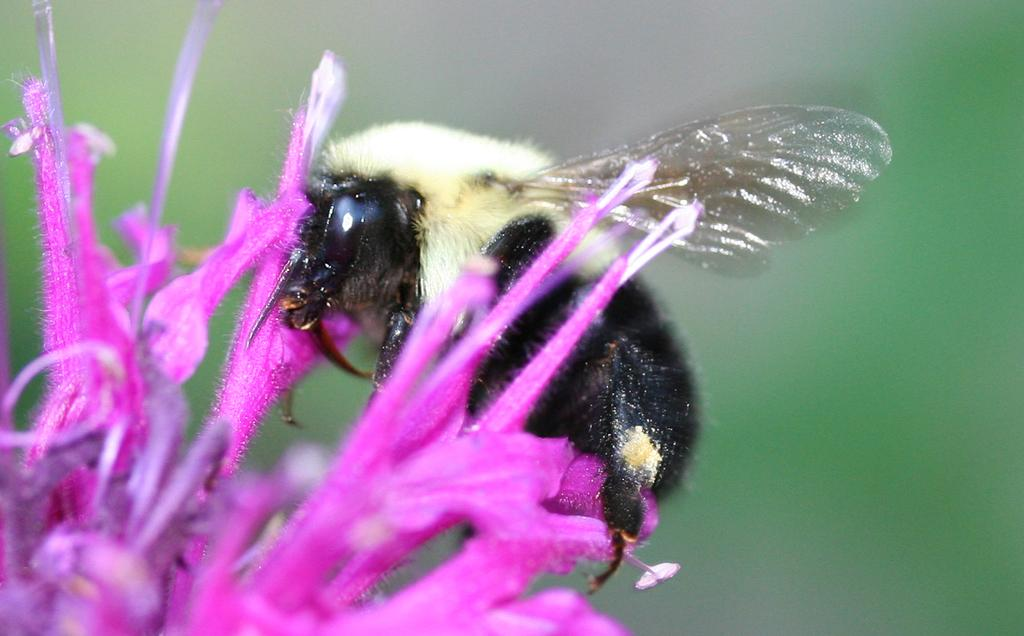What is the main subject in the foreground of the image? There is a flower in the foreground of the image. Is there anything else on the flower? Yes, there is an insect on the flower. How would you describe the background of the image? The background of the image is blurry. What type of yoke can be seen attached to the insect in the image? There is no yoke present in the image, and the insect is not attached to any yoke. How many cents are visible in the image? There are no cents present in the image. 